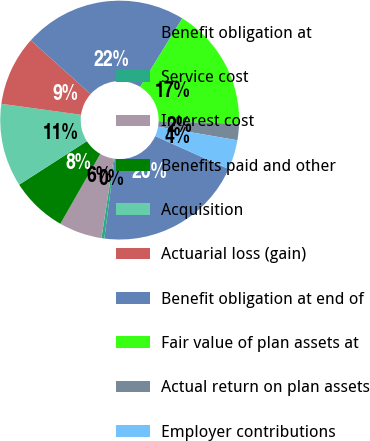Convert chart. <chart><loc_0><loc_0><loc_500><loc_500><pie_chart><fcel>Benefit obligation at<fcel>Service cost<fcel>Interest cost<fcel>Benefits paid and other<fcel>Acquisition<fcel>Actuarial loss (gain)<fcel>Benefit obligation at end of<fcel>Fair value of plan assets at<fcel>Actual return on plan assets<fcel>Employer contributions<nl><fcel>20.33%<fcel>0.39%<fcel>5.83%<fcel>7.64%<fcel>11.27%<fcel>9.46%<fcel>22.14%<fcel>16.71%<fcel>2.21%<fcel>4.02%<nl></chart> 